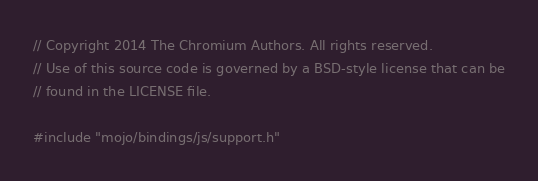Convert code to text. <code><loc_0><loc_0><loc_500><loc_500><_C++_>// Copyright 2014 The Chromium Authors. All rights reserved.
// Use of this source code is governed by a BSD-style license that can be
// found in the LICENSE file.

#include "mojo/bindings/js/support.h"
</code> 